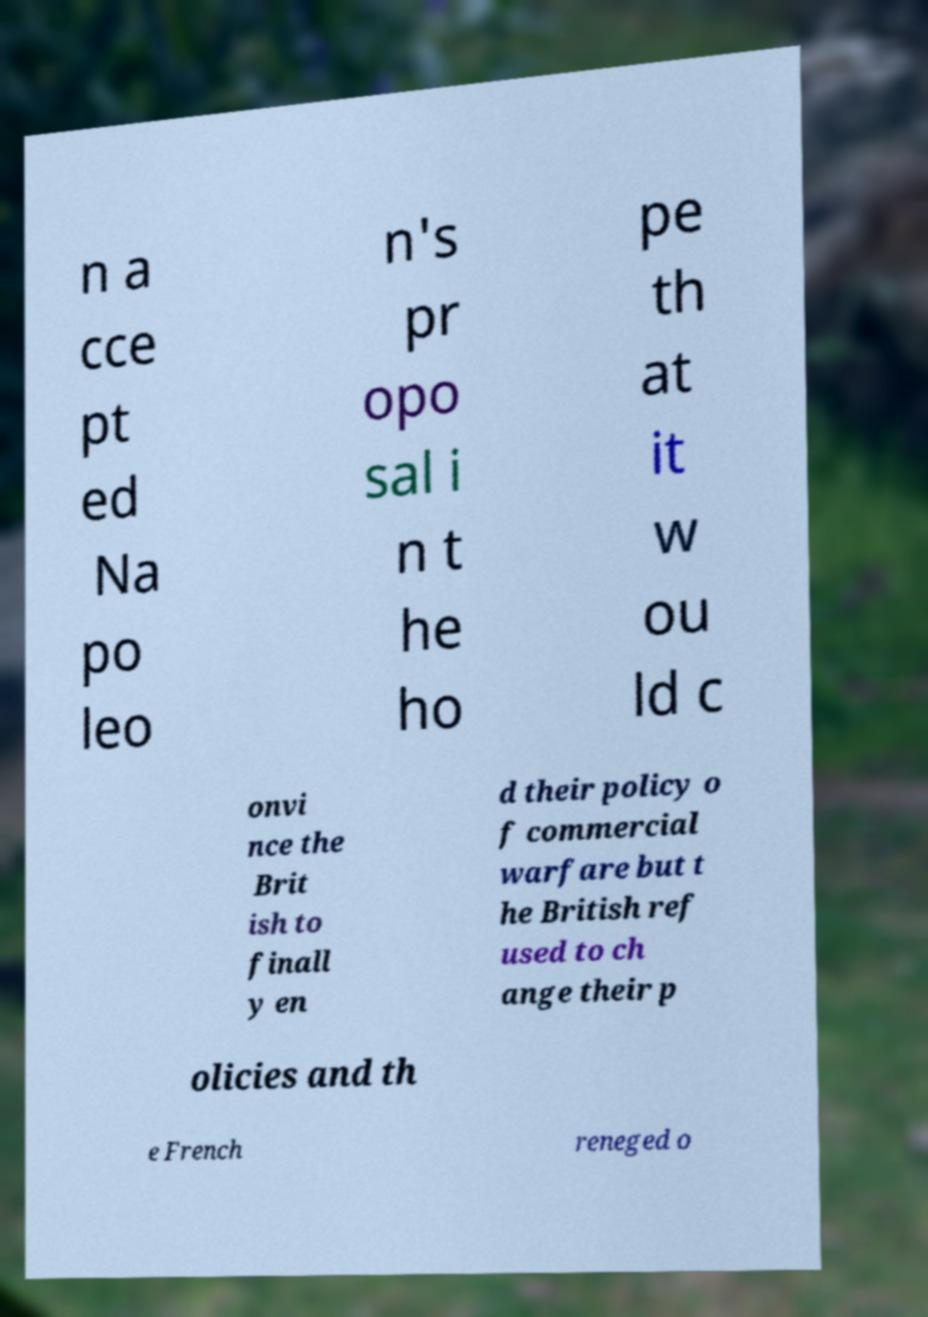Please identify and transcribe the text found in this image. n a cce pt ed Na po leo n's pr opo sal i n t he ho pe th at it w ou ld c onvi nce the Brit ish to finall y en d their policy o f commercial warfare but t he British ref used to ch ange their p olicies and th e French reneged o 